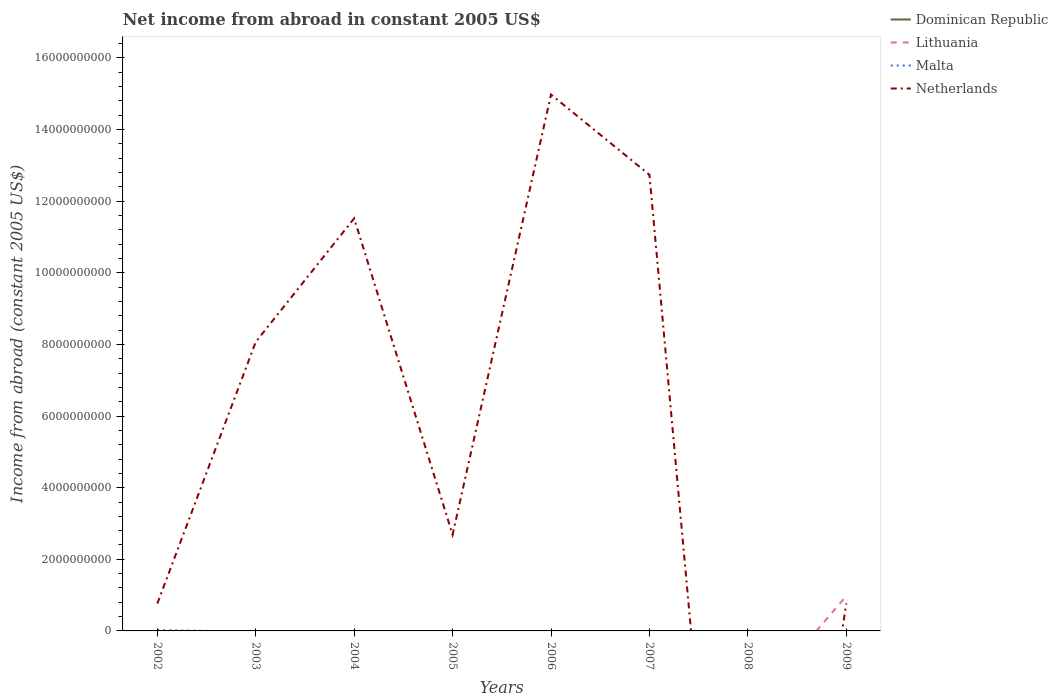How many different coloured lines are there?
Provide a succinct answer. 3. Is the number of lines equal to the number of legend labels?
Keep it short and to the point. No. What is the total net income from abroad in Netherlands in the graph?
Provide a short and direct response. -7.31e+09. What is the difference between the highest and the second highest net income from abroad in Netherlands?
Ensure brevity in your answer.  1.50e+1. What is the difference between the highest and the lowest net income from abroad in Dominican Republic?
Offer a terse response. 0. How many years are there in the graph?
Your response must be concise. 8. Does the graph contain grids?
Provide a succinct answer. No. Where does the legend appear in the graph?
Your answer should be very brief. Top right. What is the title of the graph?
Provide a succinct answer. Net income from abroad in constant 2005 US$. What is the label or title of the X-axis?
Your answer should be very brief. Years. What is the label or title of the Y-axis?
Make the answer very short. Income from abroad (constant 2005 US$). What is the Income from abroad (constant 2005 US$) of Malta in 2002?
Offer a very short reply. 2.74e+07. What is the Income from abroad (constant 2005 US$) of Netherlands in 2002?
Your answer should be compact. 7.63e+08. What is the Income from abroad (constant 2005 US$) in Malta in 2003?
Your answer should be very brief. 0. What is the Income from abroad (constant 2005 US$) in Netherlands in 2003?
Your answer should be very brief. 8.07e+09. What is the Income from abroad (constant 2005 US$) of Dominican Republic in 2004?
Give a very brief answer. 0. What is the Income from abroad (constant 2005 US$) of Malta in 2004?
Keep it short and to the point. 0. What is the Income from abroad (constant 2005 US$) in Netherlands in 2004?
Provide a succinct answer. 1.15e+1. What is the Income from abroad (constant 2005 US$) in Lithuania in 2005?
Ensure brevity in your answer.  0. What is the Income from abroad (constant 2005 US$) of Malta in 2005?
Keep it short and to the point. 0. What is the Income from abroad (constant 2005 US$) in Netherlands in 2005?
Your answer should be very brief. 2.69e+09. What is the Income from abroad (constant 2005 US$) of Dominican Republic in 2006?
Make the answer very short. 0. What is the Income from abroad (constant 2005 US$) in Malta in 2006?
Provide a short and direct response. 0. What is the Income from abroad (constant 2005 US$) of Netherlands in 2006?
Make the answer very short. 1.50e+1. What is the Income from abroad (constant 2005 US$) of Lithuania in 2007?
Give a very brief answer. 0. What is the Income from abroad (constant 2005 US$) in Malta in 2007?
Provide a short and direct response. 0. What is the Income from abroad (constant 2005 US$) of Netherlands in 2007?
Offer a very short reply. 1.27e+1. What is the Income from abroad (constant 2005 US$) of Dominican Republic in 2008?
Your response must be concise. 0. What is the Income from abroad (constant 2005 US$) in Lithuania in 2008?
Keep it short and to the point. 0. What is the Income from abroad (constant 2005 US$) of Malta in 2008?
Ensure brevity in your answer.  0. What is the Income from abroad (constant 2005 US$) in Netherlands in 2008?
Your answer should be compact. 0. What is the Income from abroad (constant 2005 US$) of Dominican Republic in 2009?
Offer a very short reply. 0. What is the Income from abroad (constant 2005 US$) of Lithuania in 2009?
Offer a terse response. 9.77e+08. What is the Income from abroad (constant 2005 US$) in Malta in 2009?
Your answer should be very brief. 0. What is the Income from abroad (constant 2005 US$) of Netherlands in 2009?
Provide a succinct answer. 7.67e+08. Across all years, what is the maximum Income from abroad (constant 2005 US$) in Lithuania?
Provide a short and direct response. 9.77e+08. Across all years, what is the maximum Income from abroad (constant 2005 US$) in Malta?
Your response must be concise. 2.74e+07. Across all years, what is the maximum Income from abroad (constant 2005 US$) of Netherlands?
Make the answer very short. 1.50e+1. Across all years, what is the minimum Income from abroad (constant 2005 US$) in Netherlands?
Make the answer very short. 0. What is the total Income from abroad (constant 2005 US$) of Dominican Republic in the graph?
Offer a very short reply. 0. What is the total Income from abroad (constant 2005 US$) of Lithuania in the graph?
Ensure brevity in your answer.  9.77e+08. What is the total Income from abroad (constant 2005 US$) of Malta in the graph?
Provide a short and direct response. 2.74e+07. What is the total Income from abroad (constant 2005 US$) in Netherlands in the graph?
Ensure brevity in your answer.  5.15e+1. What is the difference between the Income from abroad (constant 2005 US$) of Netherlands in 2002 and that in 2003?
Provide a succinct answer. -7.31e+09. What is the difference between the Income from abroad (constant 2005 US$) of Netherlands in 2002 and that in 2004?
Your response must be concise. -1.08e+1. What is the difference between the Income from abroad (constant 2005 US$) in Netherlands in 2002 and that in 2005?
Your answer should be compact. -1.93e+09. What is the difference between the Income from abroad (constant 2005 US$) in Netherlands in 2002 and that in 2006?
Your response must be concise. -1.42e+1. What is the difference between the Income from abroad (constant 2005 US$) in Netherlands in 2002 and that in 2007?
Your response must be concise. -1.20e+1. What is the difference between the Income from abroad (constant 2005 US$) of Netherlands in 2002 and that in 2009?
Make the answer very short. -3.66e+06. What is the difference between the Income from abroad (constant 2005 US$) of Netherlands in 2003 and that in 2004?
Your response must be concise. -3.45e+09. What is the difference between the Income from abroad (constant 2005 US$) of Netherlands in 2003 and that in 2005?
Your response must be concise. 5.38e+09. What is the difference between the Income from abroad (constant 2005 US$) in Netherlands in 2003 and that in 2006?
Offer a terse response. -6.91e+09. What is the difference between the Income from abroad (constant 2005 US$) in Netherlands in 2003 and that in 2007?
Offer a very short reply. -4.67e+09. What is the difference between the Income from abroad (constant 2005 US$) of Netherlands in 2003 and that in 2009?
Your response must be concise. 7.30e+09. What is the difference between the Income from abroad (constant 2005 US$) in Netherlands in 2004 and that in 2005?
Offer a terse response. 8.83e+09. What is the difference between the Income from abroad (constant 2005 US$) in Netherlands in 2004 and that in 2006?
Keep it short and to the point. -3.46e+09. What is the difference between the Income from abroad (constant 2005 US$) in Netherlands in 2004 and that in 2007?
Your response must be concise. -1.22e+09. What is the difference between the Income from abroad (constant 2005 US$) in Netherlands in 2004 and that in 2009?
Your answer should be very brief. 1.08e+1. What is the difference between the Income from abroad (constant 2005 US$) in Netherlands in 2005 and that in 2006?
Make the answer very short. -1.23e+1. What is the difference between the Income from abroad (constant 2005 US$) in Netherlands in 2005 and that in 2007?
Offer a very short reply. -1.00e+1. What is the difference between the Income from abroad (constant 2005 US$) in Netherlands in 2005 and that in 2009?
Your answer should be very brief. 1.92e+09. What is the difference between the Income from abroad (constant 2005 US$) in Netherlands in 2006 and that in 2007?
Your answer should be very brief. 2.24e+09. What is the difference between the Income from abroad (constant 2005 US$) of Netherlands in 2006 and that in 2009?
Your response must be concise. 1.42e+1. What is the difference between the Income from abroad (constant 2005 US$) in Netherlands in 2007 and that in 2009?
Your answer should be very brief. 1.20e+1. What is the difference between the Income from abroad (constant 2005 US$) in Malta in 2002 and the Income from abroad (constant 2005 US$) in Netherlands in 2003?
Make the answer very short. -8.04e+09. What is the difference between the Income from abroad (constant 2005 US$) in Malta in 2002 and the Income from abroad (constant 2005 US$) in Netherlands in 2004?
Give a very brief answer. -1.15e+1. What is the difference between the Income from abroad (constant 2005 US$) in Malta in 2002 and the Income from abroad (constant 2005 US$) in Netherlands in 2005?
Offer a very short reply. -2.66e+09. What is the difference between the Income from abroad (constant 2005 US$) in Malta in 2002 and the Income from abroad (constant 2005 US$) in Netherlands in 2006?
Ensure brevity in your answer.  -1.50e+1. What is the difference between the Income from abroad (constant 2005 US$) in Malta in 2002 and the Income from abroad (constant 2005 US$) in Netherlands in 2007?
Provide a short and direct response. -1.27e+1. What is the difference between the Income from abroad (constant 2005 US$) in Malta in 2002 and the Income from abroad (constant 2005 US$) in Netherlands in 2009?
Offer a very short reply. -7.39e+08. What is the average Income from abroad (constant 2005 US$) of Dominican Republic per year?
Your answer should be compact. 0. What is the average Income from abroad (constant 2005 US$) of Lithuania per year?
Offer a terse response. 1.22e+08. What is the average Income from abroad (constant 2005 US$) of Malta per year?
Offer a terse response. 3.43e+06. What is the average Income from abroad (constant 2005 US$) of Netherlands per year?
Your answer should be compact. 6.44e+09. In the year 2002, what is the difference between the Income from abroad (constant 2005 US$) in Malta and Income from abroad (constant 2005 US$) in Netherlands?
Provide a succinct answer. -7.36e+08. In the year 2009, what is the difference between the Income from abroad (constant 2005 US$) of Lithuania and Income from abroad (constant 2005 US$) of Netherlands?
Your answer should be compact. 2.10e+08. What is the ratio of the Income from abroad (constant 2005 US$) of Netherlands in 2002 to that in 2003?
Offer a very short reply. 0.09. What is the ratio of the Income from abroad (constant 2005 US$) in Netherlands in 2002 to that in 2004?
Offer a very short reply. 0.07. What is the ratio of the Income from abroad (constant 2005 US$) of Netherlands in 2002 to that in 2005?
Give a very brief answer. 0.28. What is the ratio of the Income from abroad (constant 2005 US$) in Netherlands in 2002 to that in 2006?
Provide a succinct answer. 0.05. What is the ratio of the Income from abroad (constant 2005 US$) of Netherlands in 2002 to that in 2007?
Offer a very short reply. 0.06. What is the ratio of the Income from abroad (constant 2005 US$) of Netherlands in 2002 to that in 2009?
Keep it short and to the point. 1. What is the ratio of the Income from abroad (constant 2005 US$) in Netherlands in 2003 to that in 2004?
Keep it short and to the point. 0.7. What is the ratio of the Income from abroad (constant 2005 US$) in Netherlands in 2003 to that in 2005?
Keep it short and to the point. 3. What is the ratio of the Income from abroad (constant 2005 US$) of Netherlands in 2003 to that in 2006?
Your answer should be compact. 0.54. What is the ratio of the Income from abroad (constant 2005 US$) of Netherlands in 2003 to that in 2007?
Make the answer very short. 0.63. What is the ratio of the Income from abroad (constant 2005 US$) in Netherlands in 2003 to that in 2009?
Keep it short and to the point. 10.52. What is the ratio of the Income from abroad (constant 2005 US$) of Netherlands in 2004 to that in 2005?
Give a very brief answer. 4.28. What is the ratio of the Income from abroad (constant 2005 US$) of Netherlands in 2004 to that in 2006?
Offer a very short reply. 0.77. What is the ratio of the Income from abroad (constant 2005 US$) of Netherlands in 2004 to that in 2007?
Your response must be concise. 0.9. What is the ratio of the Income from abroad (constant 2005 US$) of Netherlands in 2004 to that in 2009?
Provide a short and direct response. 15.02. What is the ratio of the Income from abroad (constant 2005 US$) in Netherlands in 2005 to that in 2006?
Your answer should be very brief. 0.18. What is the ratio of the Income from abroad (constant 2005 US$) of Netherlands in 2005 to that in 2007?
Your answer should be compact. 0.21. What is the ratio of the Income from abroad (constant 2005 US$) in Netherlands in 2005 to that in 2009?
Give a very brief answer. 3.51. What is the ratio of the Income from abroad (constant 2005 US$) in Netherlands in 2006 to that in 2007?
Provide a succinct answer. 1.18. What is the ratio of the Income from abroad (constant 2005 US$) of Netherlands in 2006 to that in 2009?
Your answer should be very brief. 19.53. What is the ratio of the Income from abroad (constant 2005 US$) in Netherlands in 2007 to that in 2009?
Provide a succinct answer. 16.61. What is the difference between the highest and the second highest Income from abroad (constant 2005 US$) of Netherlands?
Provide a short and direct response. 2.24e+09. What is the difference between the highest and the lowest Income from abroad (constant 2005 US$) in Lithuania?
Provide a short and direct response. 9.77e+08. What is the difference between the highest and the lowest Income from abroad (constant 2005 US$) of Malta?
Keep it short and to the point. 2.74e+07. What is the difference between the highest and the lowest Income from abroad (constant 2005 US$) in Netherlands?
Your response must be concise. 1.50e+1. 